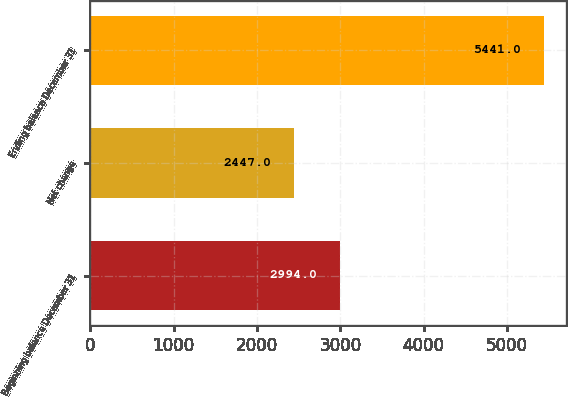Convert chart. <chart><loc_0><loc_0><loc_500><loc_500><bar_chart><fcel>Beginning balance December 31<fcel>Net change<fcel>Ending balance December 31<nl><fcel>2994<fcel>2447<fcel>5441<nl></chart> 